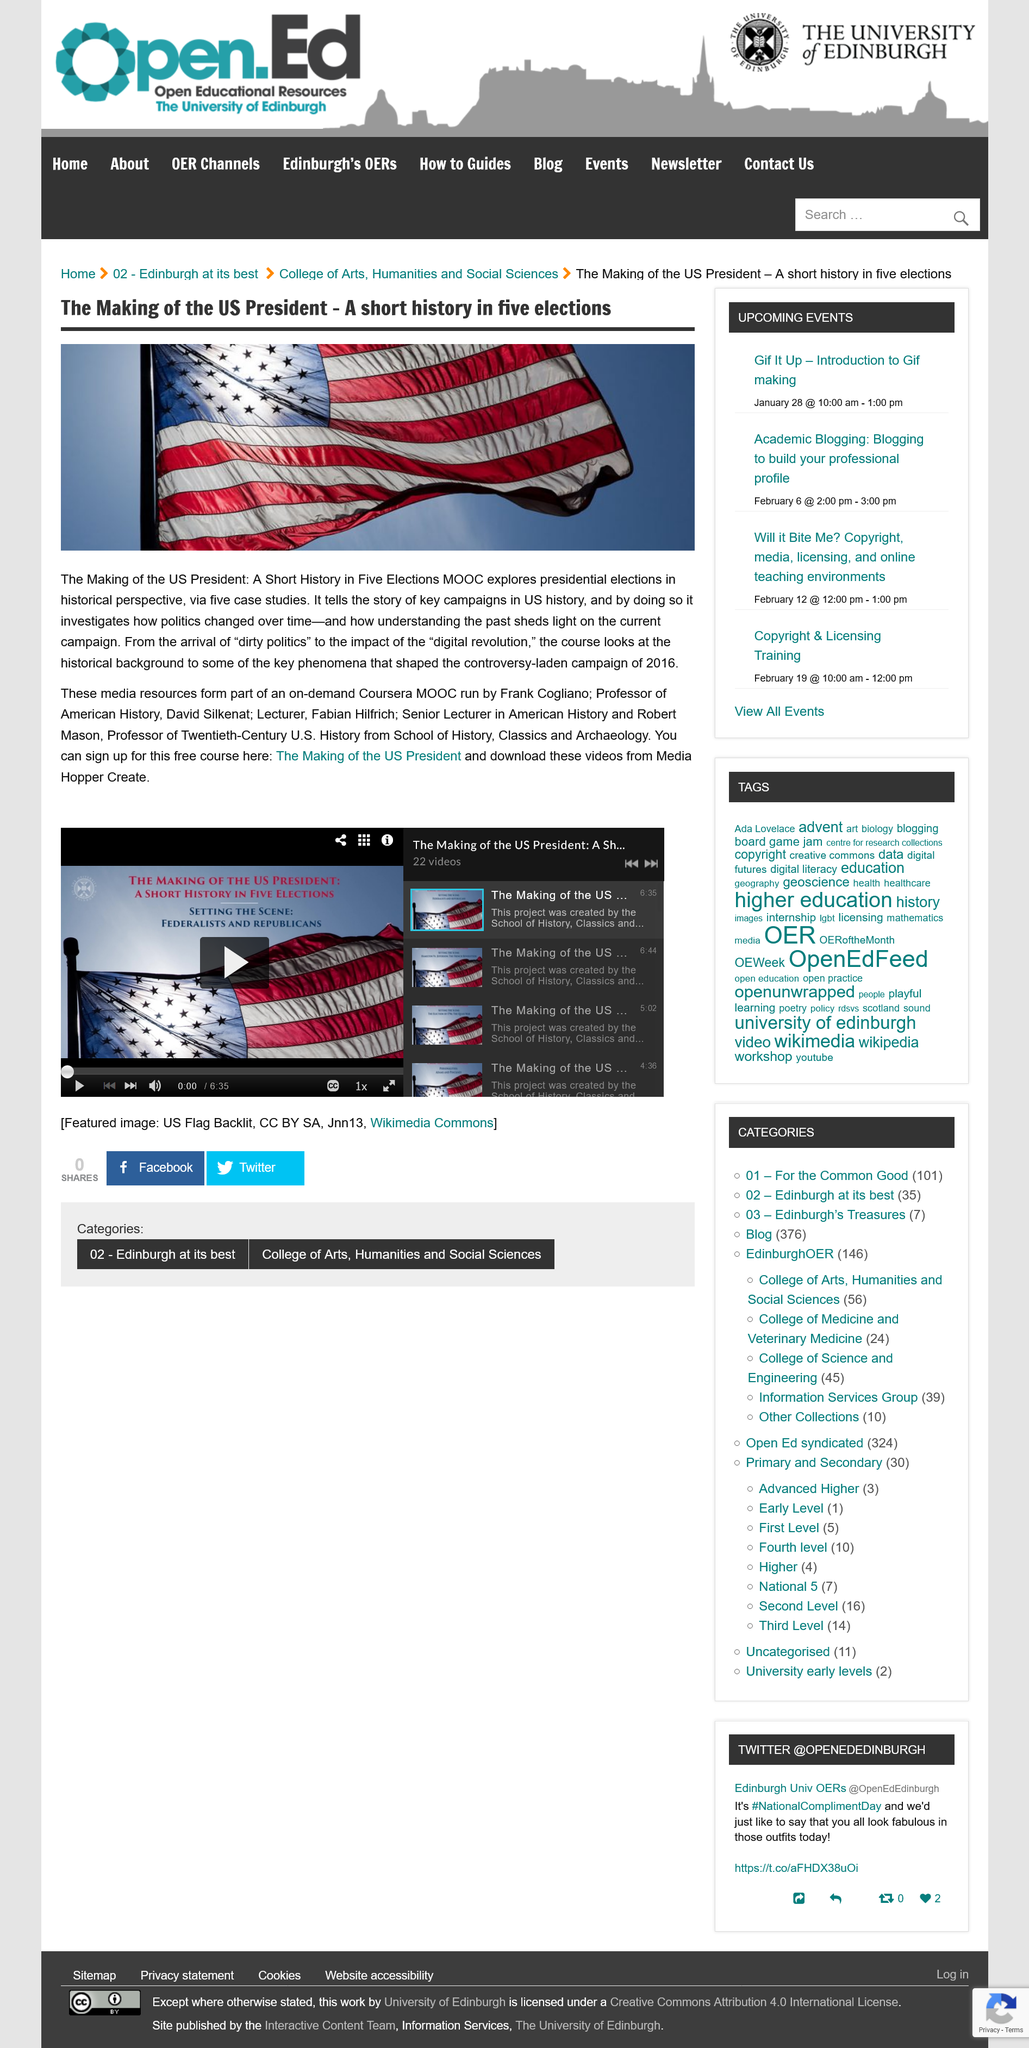Give some essential details in this illustration. The Professor of American History named in the text is David Silkenat. This event covers five elections. You can download the videos from Media Hopper Create. 